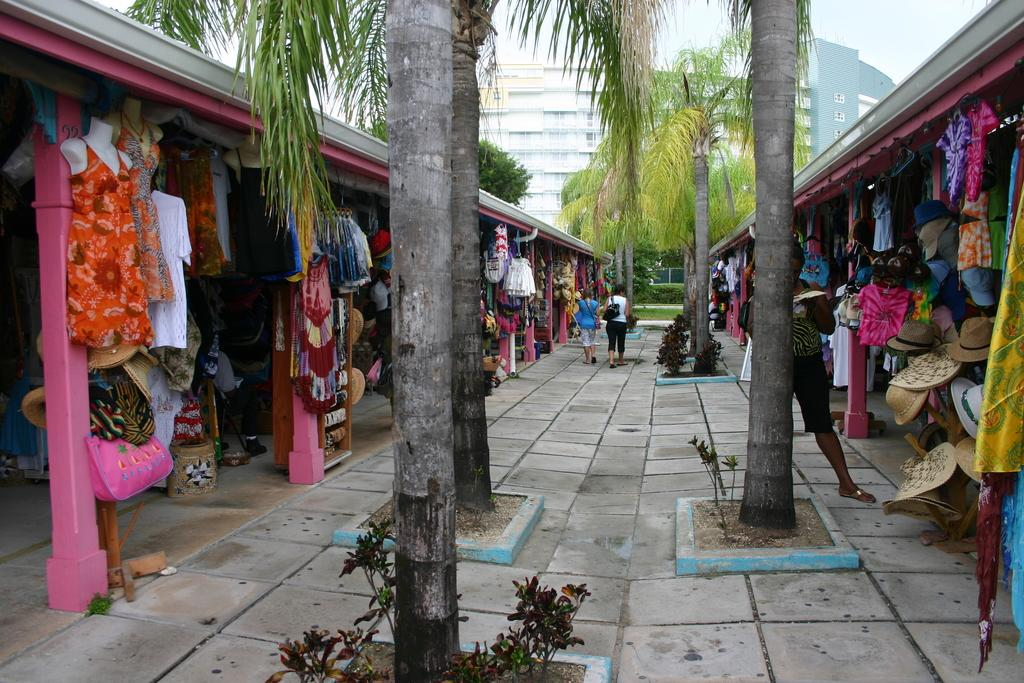How many people are in the image? There is a group of people in the image, but the exact number cannot be determined from the provided facts. What are the people in the image wearing? The people in the image are wearing clothes. What type of headwear can be seen in the image? There are caps in the image. What type of natural environment is visible in the image? There are trees in the image. What type of man-made structures can be seen in the background of the image? There are buildings in the background of the image. What type of rings can be seen on the trees in the image? There are no rings visible on the trees in the image. 